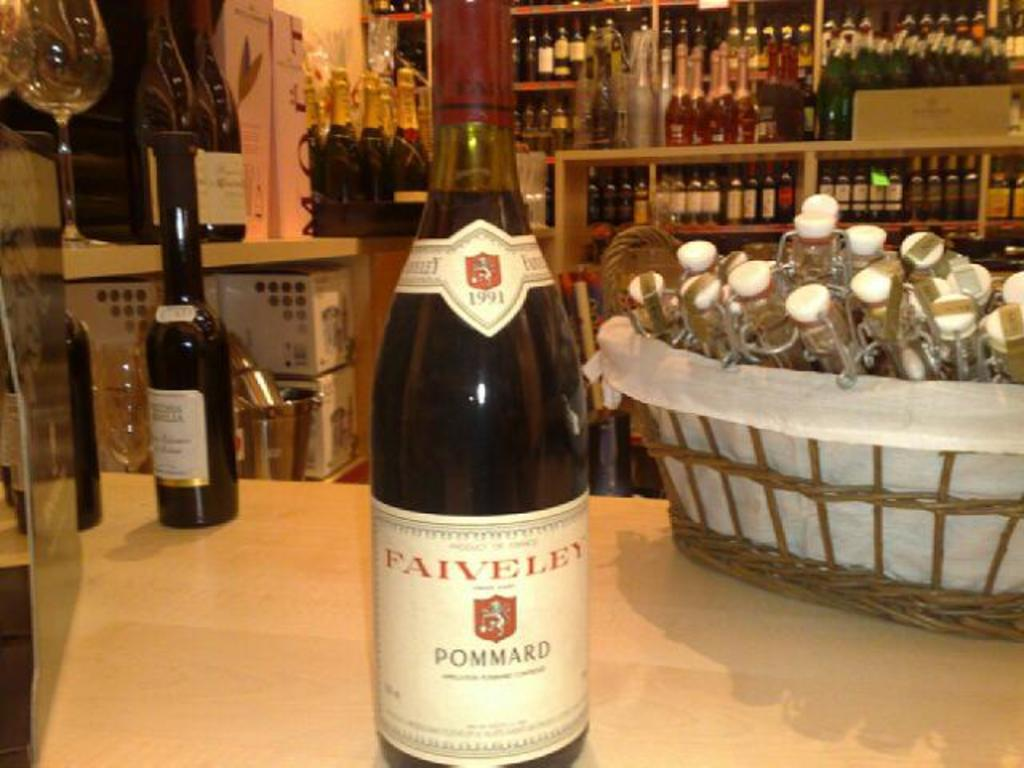<image>
Provide a brief description of the given image. A bottle of Faiveley Pommard wine sits on a counter in a wine merchant shop. 